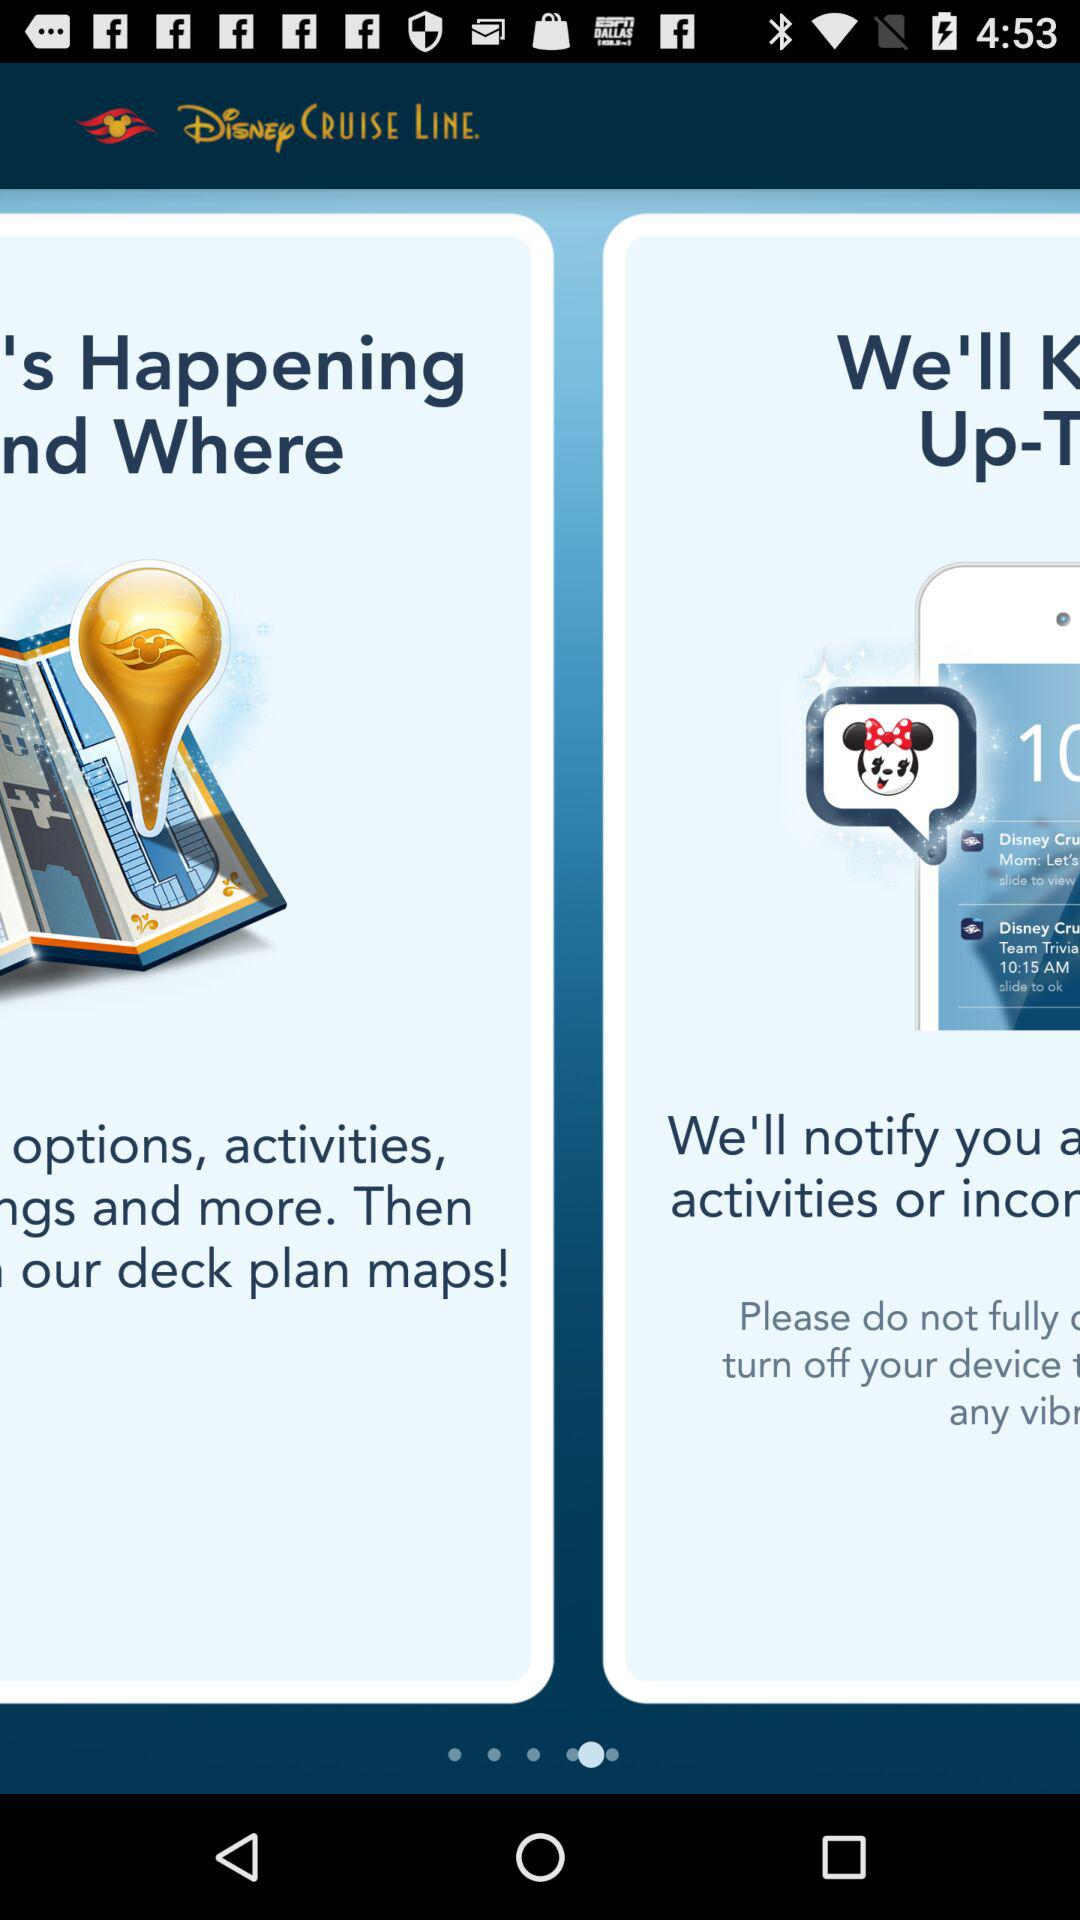What is the application name? The application name is "Disney Cruise Line". 